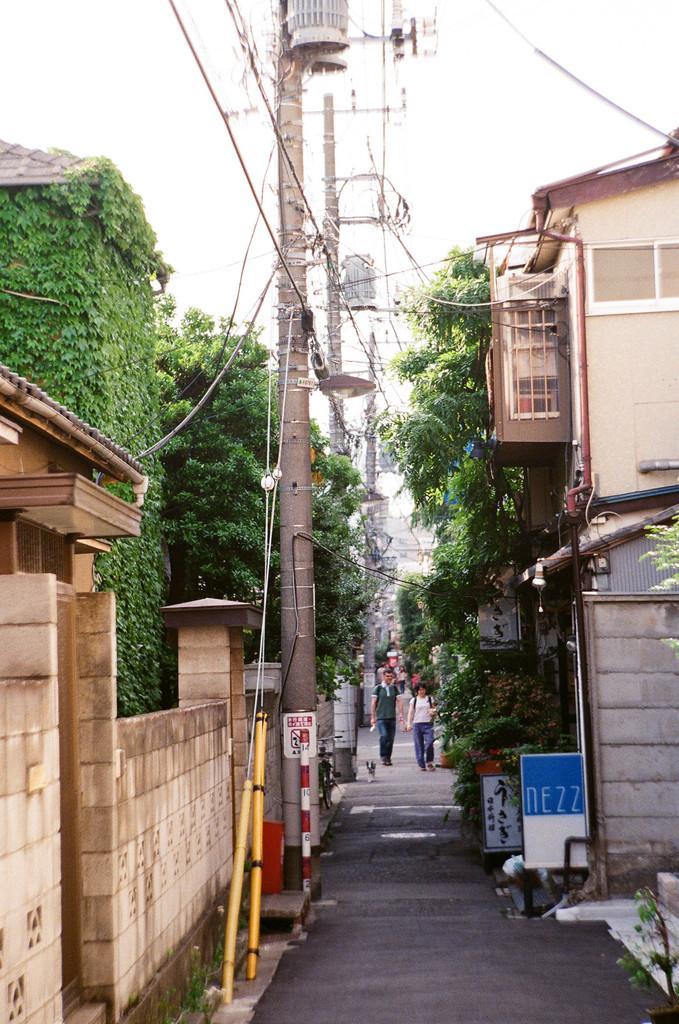Could you give a brief overview of what you see in this image? There is a road. On that two people are walking. On the right side there is a building with window. Also there are trees. On the left side there are electric poles with wires, fencing wall and building with plants on that. Also there are trees. In the background there is sky. Also there is a sign board on the pole. 